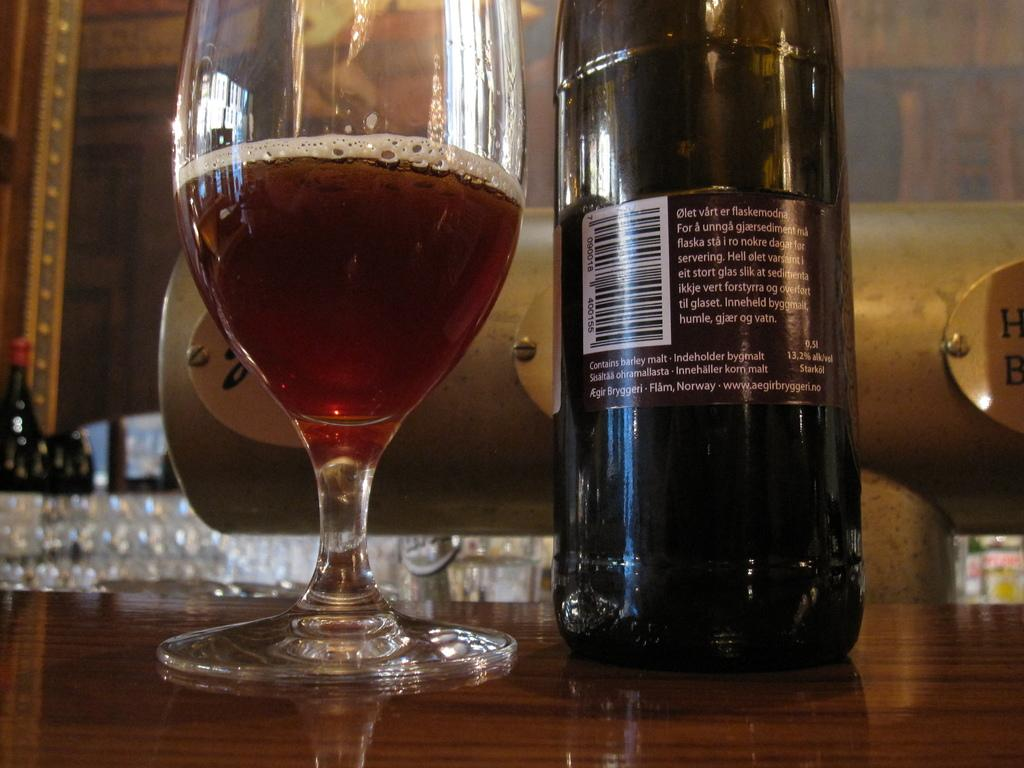<image>
Provide a brief description of the given image. A barley beer made in Flam Norway by Aegir Bryggeri. 